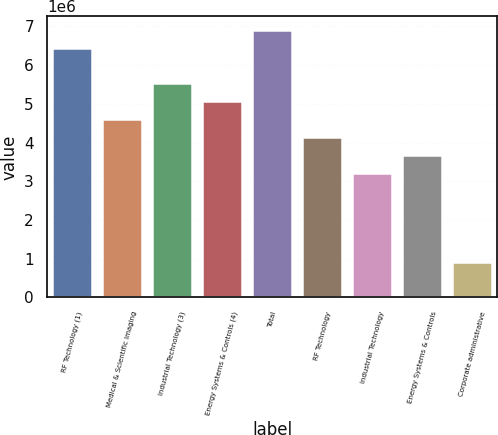Convert chart. <chart><loc_0><loc_0><loc_500><loc_500><bar_chart><fcel>RF Technology (1)<fcel>Medical & Scientific Imaging<fcel>Industrial Technology (3)<fcel>Energy Systems & Controls (4)<fcel>Total<fcel>RF Technology<fcel>Industrial Technology<fcel>Energy Systems & Controls<fcel>Corporate administrative<nl><fcel>6.45046e+06<fcel>4.60747e+06<fcel>5.52897e+06<fcel>5.06822e+06<fcel>6.91121e+06<fcel>4.14672e+06<fcel>3.22523e+06<fcel>3.68598e+06<fcel>921494<nl></chart> 